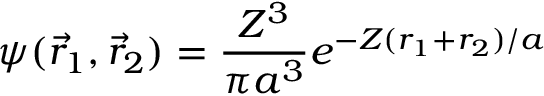Convert formula to latex. <formula><loc_0><loc_0><loc_500><loc_500>\psi ( { \vec { r } } _ { 1 } , { \vec { r } } _ { 2 } ) = { \frac { Z ^ { 3 } } { \pi a ^ { 3 } } } e ^ { - Z ( r _ { 1 } + r _ { 2 } ) / a }</formula> 